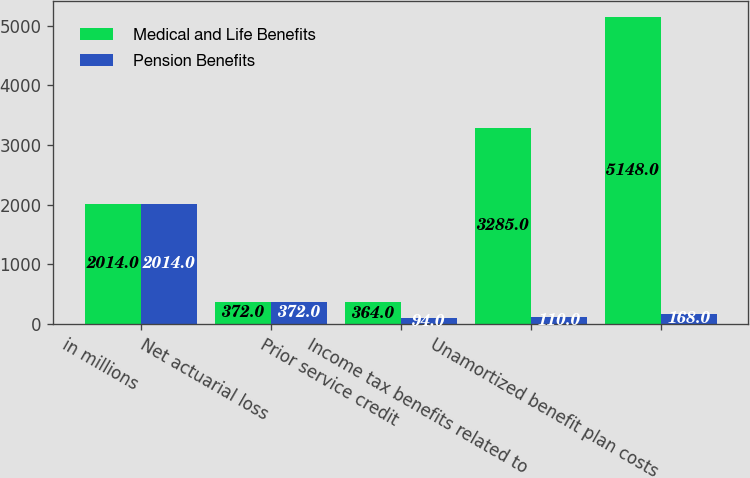Convert chart to OTSL. <chart><loc_0><loc_0><loc_500><loc_500><stacked_bar_chart><ecel><fcel>in millions<fcel>Net actuarial loss<fcel>Prior service credit<fcel>Income tax benefits related to<fcel>Unamortized benefit plan costs<nl><fcel>Medical and Life Benefits<fcel>2014<fcel>372<fcel>364<fcel>3285<fcel>5148<nl><fcel>Pension Benefits<fcel>2014<fcel>372<fcel>94<fcel>110<fcel>168<nl></chart> 